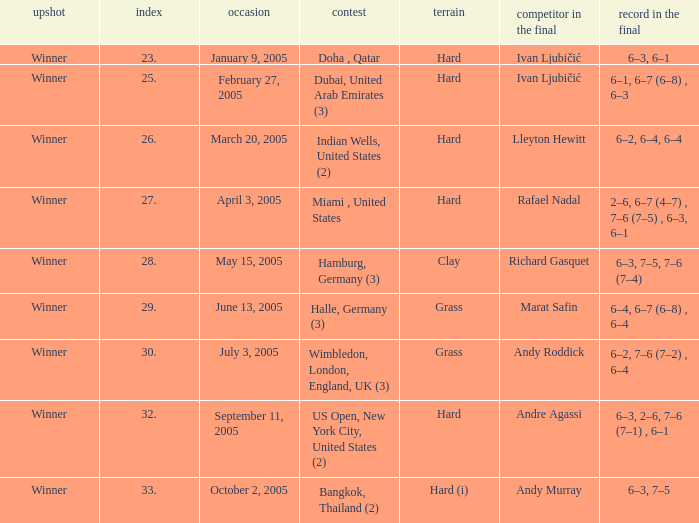In the championship Miami , United States, what is the score in the final? 2–6, 6–7 (4–7) , 7–6 (7–5) , 6–3, 6–1. 